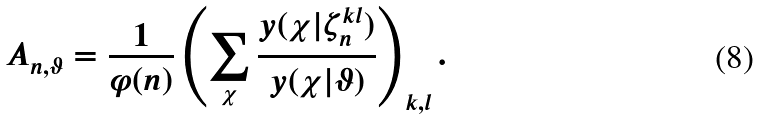Convert formula to latex. <formula><loc_0><loc_0><loc_500><loc_500>A _ { n , \vartheta } = \frac { 1 } { \varphi ( n ) } \left ( \sum _ { \chi } \frac { y ( \chi | \zeta _ { n } ^ { k l } ) } { y ( \chi | \vartheta ) } \right ) _ { k , l } .</formula> 